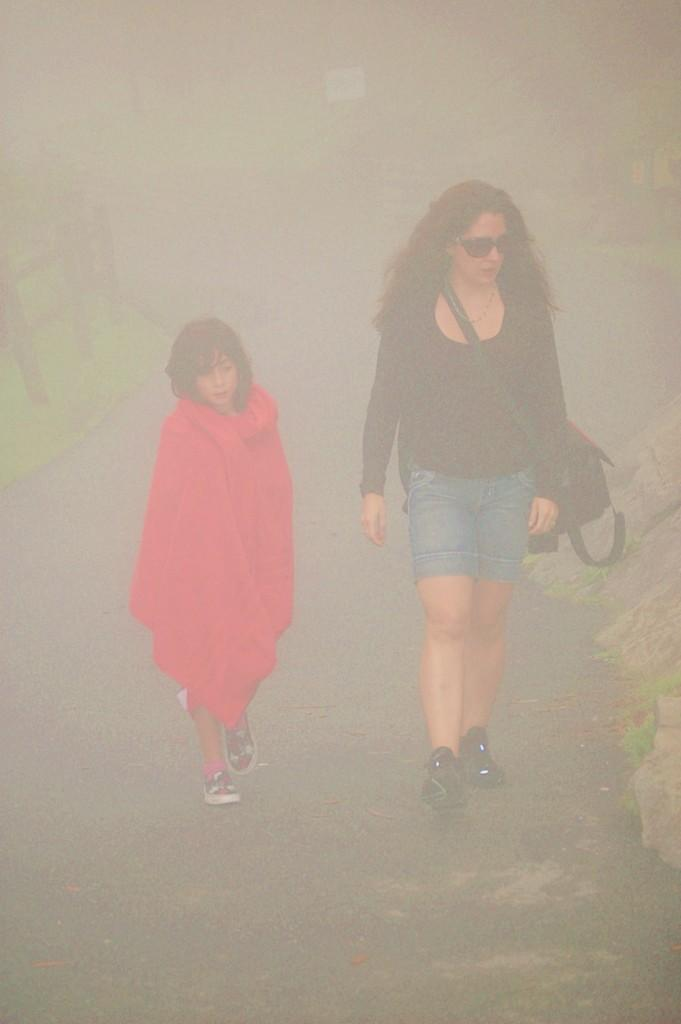What are the persons in the image doing? The persons in the image are walking. How would you describe the background of the image? The background of the image is foggy. What type of vegetation is present on the left side of the image? There is grass on the ground on the left side of the image. What can be seen on the left side of the image besides the grass? There is a fence on the left side of the image. What type of roll can be seen in the image? There is no roll present in the image. What historical event is depicted in the image? There is no historical event depicted in the image; it shows persons walking in a foggy background with grass and a fence on the left side. 